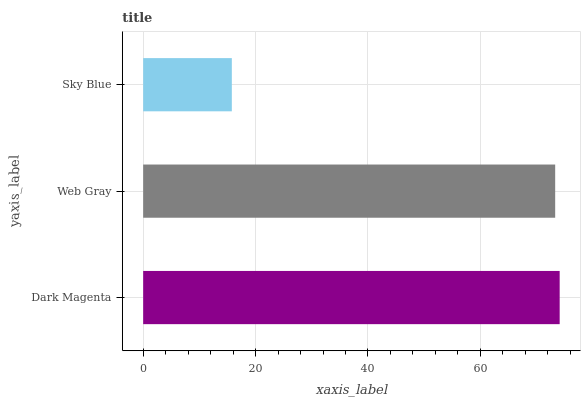Is Sky Blue the minimum?
Answer yes or no. Yes. Is Dark Magenta the maximum?
Answer yes or no. Yes. Is Web Gray the minimum?
Answer yes or no. No. Is Web Gray the maximum?
Answer yes or no. No. Is Dark Magenta greater than Web Gray?
Answer yes or no. Yes. Is Web Gray less than Dark Magenta?
Answer yes or no. Yes. Is Web Gray greater than Dark Magenta?
Answer yes or no. No. Is Dark Magenta less than Web Gray?
Answer yes or no. No. Is Web Gray the high median?
Answer yes or no. Yes. Is Web Gray the low median?
Answer yes or no. Yes. Is Dark Magenta the high median?
Answer yes or no. No. Is Sky Blue the low median?
Answer yes or no. No. 